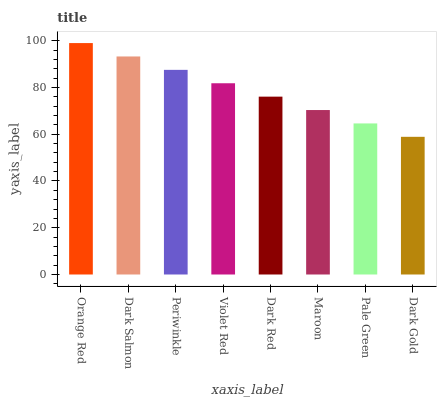Is Dark Gold the minimum?
Answer yes or no. Yes. Is Orange Red the maximum?
Answer yes or no. Yes. Is Dark Salmon the minimum?
Answer yes or no. No. Is Dark Salmon the maximum?
Answer yes or no. No. Is Orange Red greater than Dark Salmon?
Answer yes or no. Yes. Is Dark Salmon less than Orange Red?
Answer yes or no. Yes. Is Dark Salmon greater than Orange Red?
Answer yes or no. No. Is Orange Red less than Dark Salmon?
Answer yes or no. No. Is Violet Red the high median?
Answer yes or no. Yes. Is Dark Red the low median?
Answer yes or no. Yes. Is Dark Salmon the high median?
Answer yes or no. No. Is Violet Red the low median?
Answer yes or no. No. 